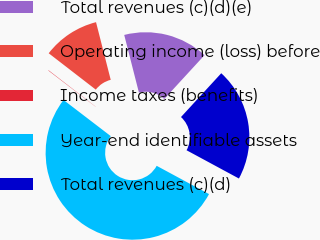Convert chart. <chart><loc_0><loc_0><loc_500><loc_500><pie_chart><fcel>Total revenues (c)(d)(e)<fcel>Operating income (loss) before<fcel>Income taxes (benefits)<fcel>Year-end identifiable assets<fcel>Total revenues (c)(d)<nl><fcel>15.8%<fcel>10.56%<fcel>0.07%<fcel>52.51%<fcel>21.05%<nl></chart> 